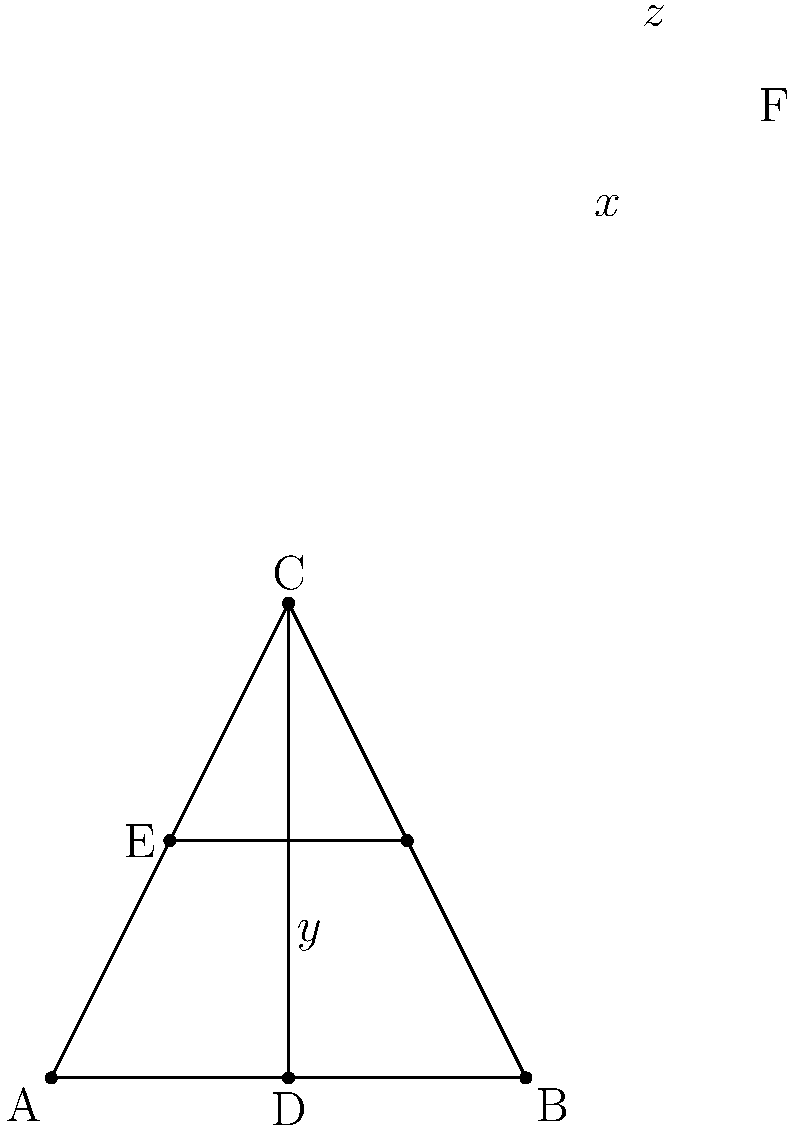At a multicultural job fair, queue lines for different employers intersect, forming various angles. In the diagram above, line EF represents a queue for a language interpretation service, while line CD represents a queue for a global diversity consultant. Given that $\angle ACD = 50°$ and $\angle ABC = 60°$, find the value of $x + y + z$. Let's approach this step-by-step:

1) In triangle ABC:
   $\angle BAC + \angle ABC + \angle BCA = 180°$ (sum of angles in a triangle)
   $\angle BAC + 60° + 50° = 180°$
   $\angle BAC = 70°$

2) $\angle ACD = 50°$, so $\angle ADE = 50°$ (vertically opposite angles)

3) In triangle ADE:
   $\angle DAE + \angle ADE + x = 180°$ (sum of angles in a triangle)
   $70° + 50° + x = 180°$
   $x = 60°$

4) $\angle ABC = 60°$, so $\angle DBF = 60°$ (vertically opposite angles)

5) In triangle BDF:
   $y + 60° + \angle BFD = 180°$ (sum of angles in a triangle)
   $y + 60° + 50° = 180°$ (note that $\angle BFD = \angle ADE = 50°$)
   $y = 70°$

6) In triangle CDE:
   $z + 50° + 50° = 180°$ (sum of angles in a triangle)
   $z = 80°$

7) Therefore, $x + y + z = 60° + 70° + 80° = 210°$
Answer: $210°$ 